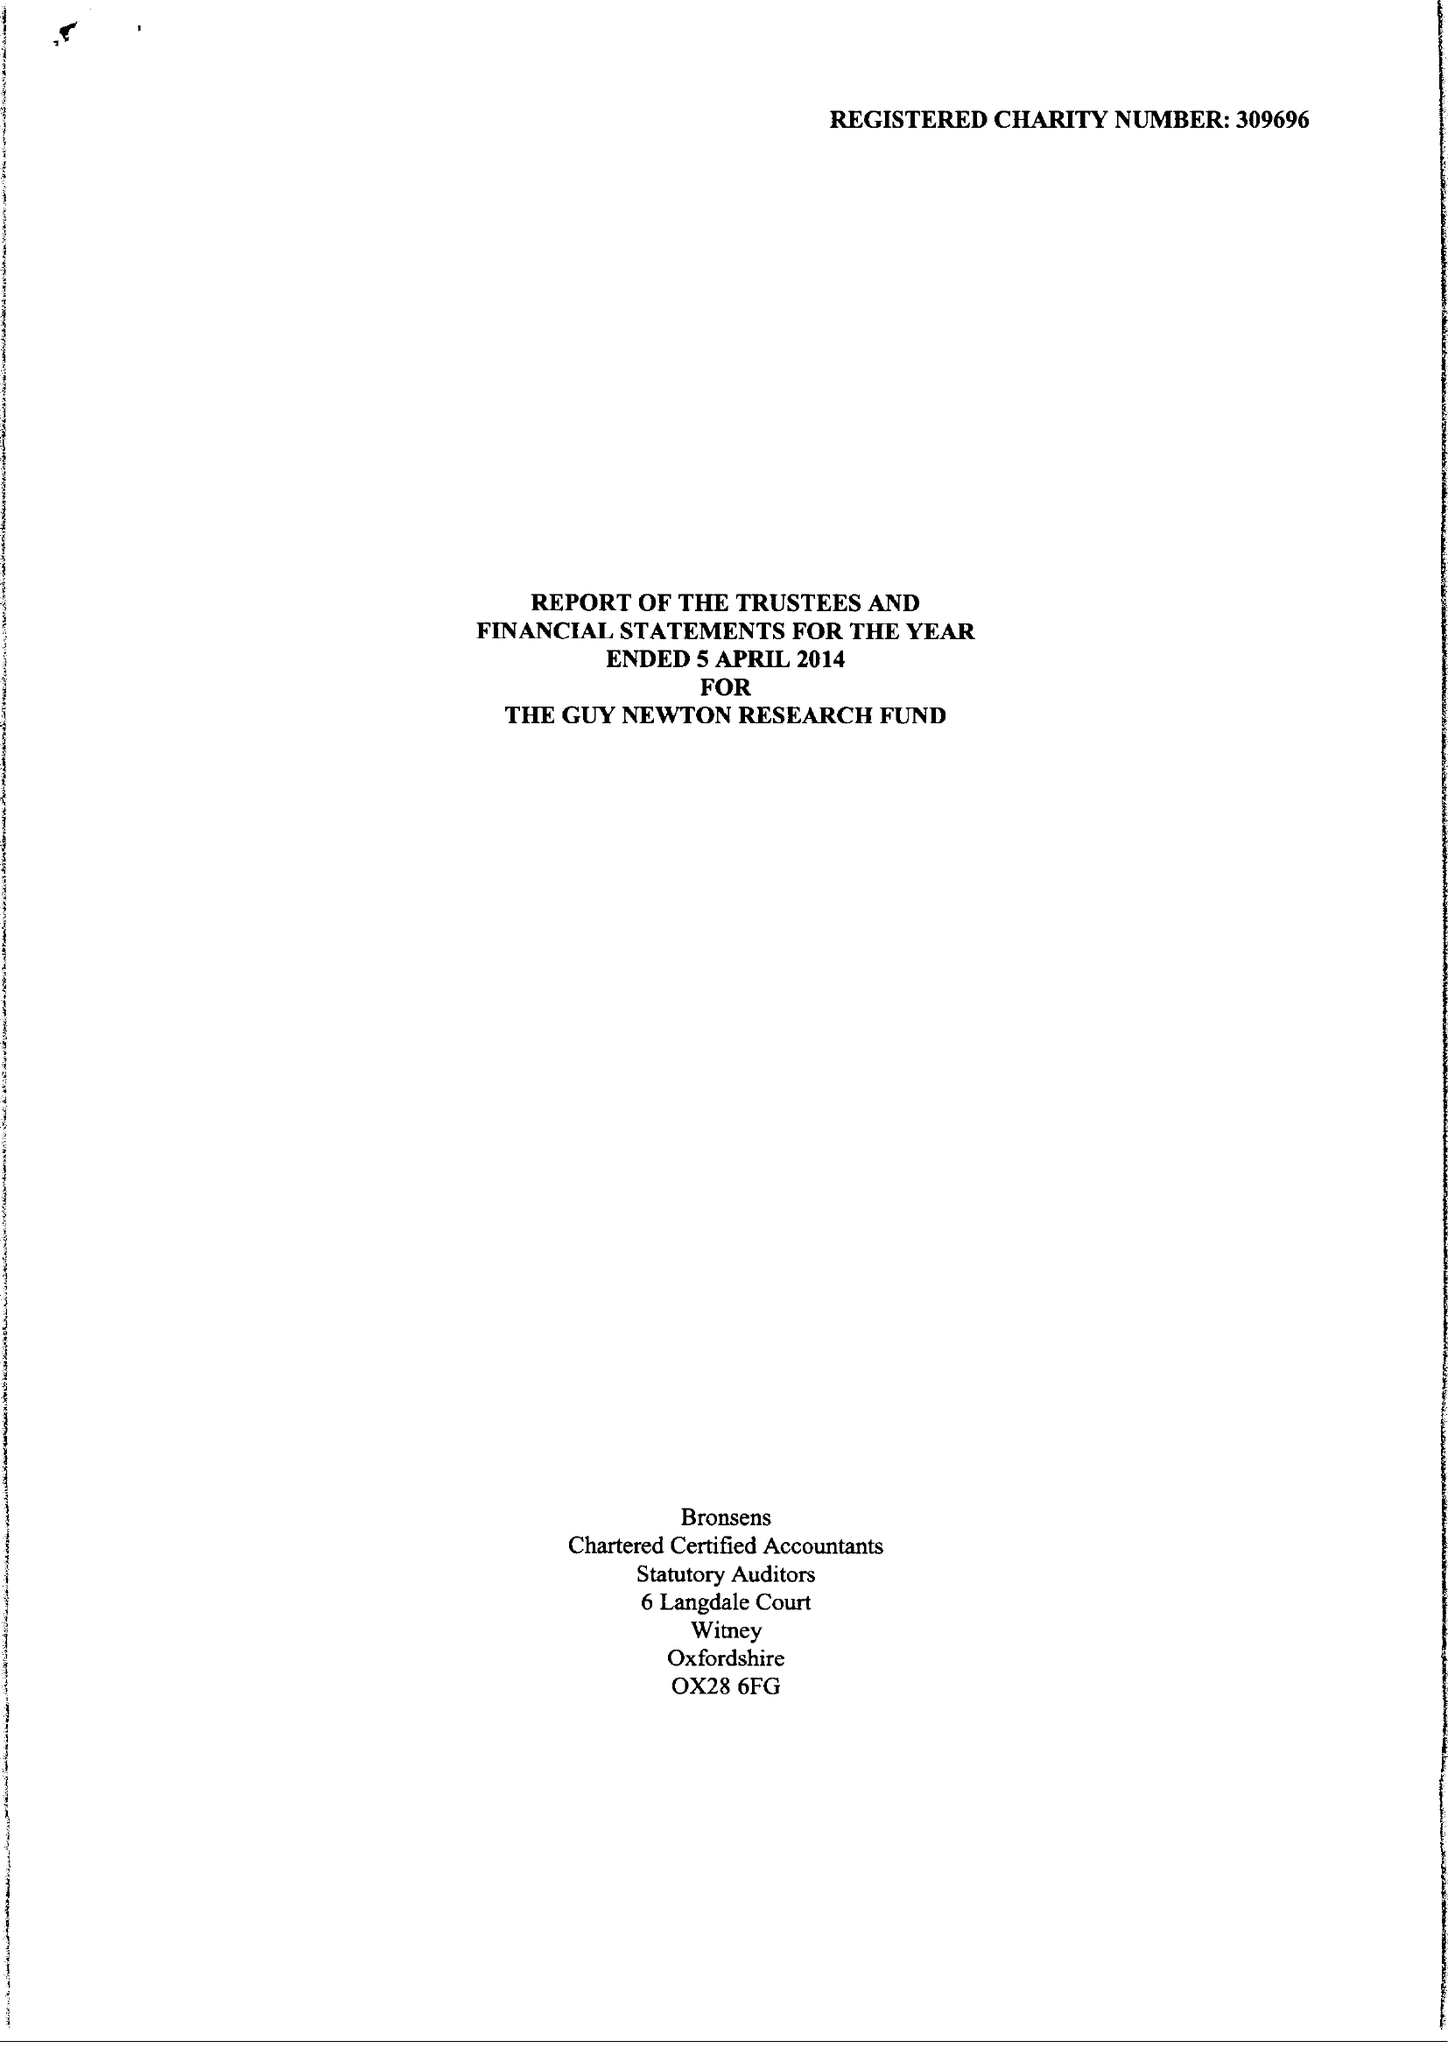What is the value for the charity_name?
Answer the question using a single word or phrase. The Guy Newton Research Fund 